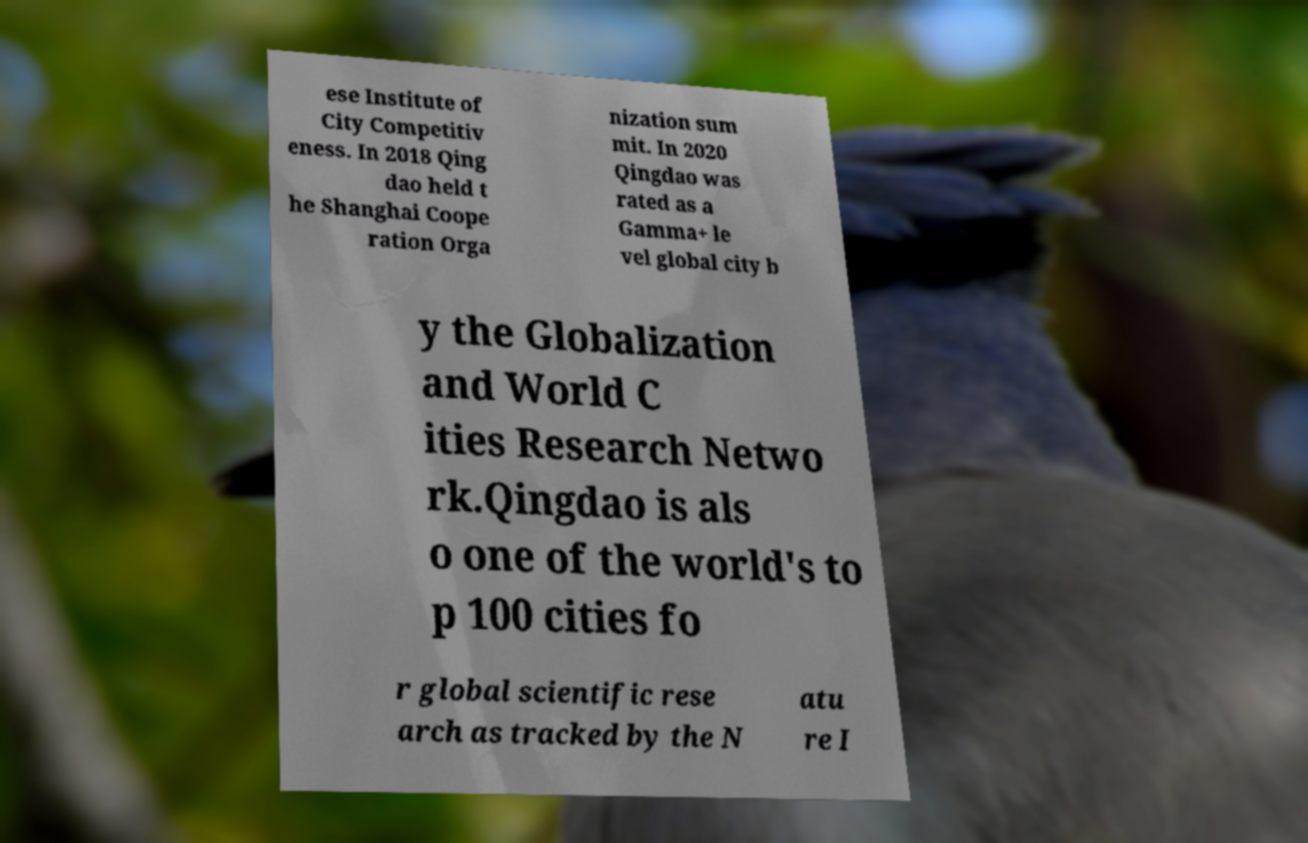Please read and relay the text visible in this image. What does it say? ese Institute of City Competitiv eness. In 2018 Qing dao held t he Shanghai Coope ration Orga nization sum mit. In 2020 Qingdao was rated as a Gamma+ le vel global city b y the Globalization and World C ities Research Netwo rk.Qingdao is als o one of the world's to p 100 cities fo r global scientific rese arch as tracked by the N atu re I 